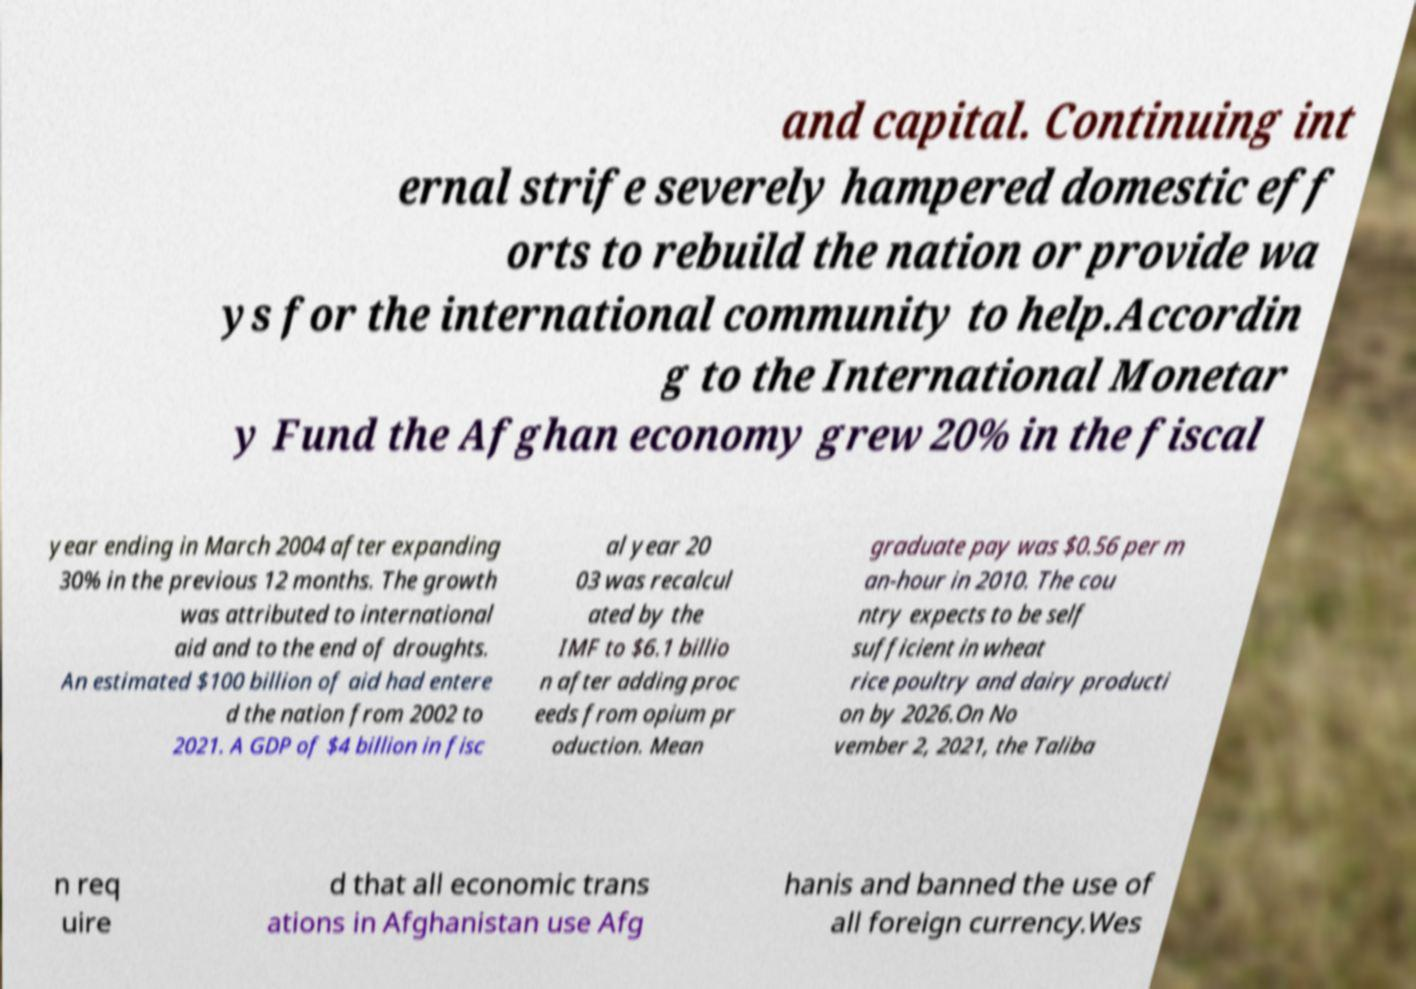Could you extract and type out the text from this image? and capital. Continuing int ernal strife severely hampered domestic eff orts to rebuild the nation or provide wa ys for the international community to help.Accordin g to the International Monetar y Fund the Afghan economy grew 20% in the fiscal year ending in March 2004 after expanding 30% in the previous 12 months. The growth was attributed to international aid and to the end of droughts. An estimated $100 billion of aid had entere d the nation from 2002 to 2021. A GDP of $4 billion in fisc al year 20 03 was recalcul ated by the IMF to $6.1 billio n after adding proc eeds from opium pr oduction. Mean graduate pay was $0.56 per m an-hour in 2010. The cou ntry expects to be self sufficient in wheat rice poultry and dairy producti on by 2026.On No vember 2, 2021, the Taliba n req uire d that all economic trans ations in Afghanistan use Afg hanis and banned the use of all foreign currency.Wes 